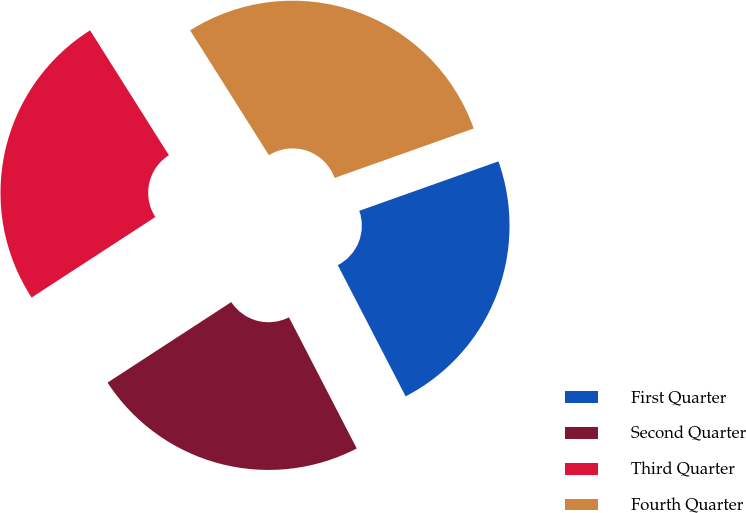Convert chart. <chart><loc_0><loc_0><loc_500><loc_500><pie_chart><fcel>First Quarter<fcel>Second Quarter<fcel>Third Quarter<fcel>Fourth Quarter<nl><fcel>22.84%<fcel>23.41%<fcel>25.22%<fcel>28.53%<nl></chart> 